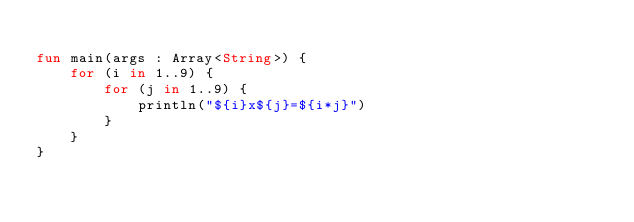<code> <loc_0><loc_0><loc_500><loc_500><_Kotlin_>
fun main(args : Array<String>) {
    for (i in 1..9) {
        for (j in 1..9) {
            println("${i}x${j}=${i*j}")
        }
    }
}
</code> 